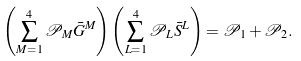Convert formula to latex. <formula><loc_0><loc_0><loc_500><loc_500>\left ( \sum _ { M = 1 } ^ { 4 } \mathcal { P } _ { M } \bar { G } ^ { M } \right ) \left ( \sum _ { L = 1 } ^ { 4 } \mathcal { P } _ { L } \bar { S } ^ { L } \right ) = \mathcal { P } _ { 1 } + \mathcal { P } _ { 2 } .</formula> 